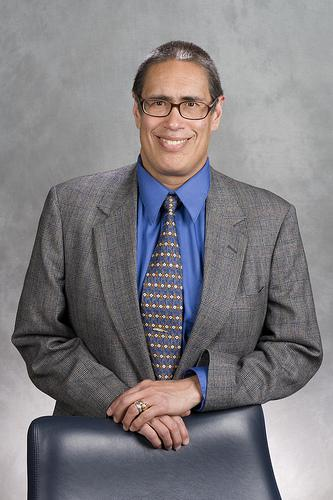Question: where are these person's hands situated?
Choices:
A. In their pockets.
B. On their heads.
C. On top of a chair.
D. On the keyboard.
Answer with the letter. Answer: C Question: how many hands are visible?
Choices:
A. One.
B. Three.
C. Two.
D. Four.
Answer with the letter. Answer: C Question: what color is this person's shirt?
Choices:
A. Red.
B. Yellow.
C. Blue.
D. Green.
Answer with the letter. Answer: C Question: what is around this person's neck?
Choices:
A. Collar.
B. Hands.
C. A tie.
D. Tattoo.
Answer with the letter. Answer: C 